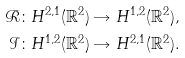Convert formula to latex. <formula><loc_0><loc_0><loc_500><loc_500>\mathcal { R } & \colon H ^ { 2 , 1 } ( \mathbb { R } ^ { 2 } ) \rightarrow H ^ { 1 , 2 } ( \mathbb { R } ^ { 2 } ) , \\ \mathcal { I } & \colon H ^ { 1 , 2 } ( \mathbb { R } ^ { 2 } ) \rightarrow H ^ { 2 , 1 } ( \mathbb { R } ^ { 2 } ) .</formula> 